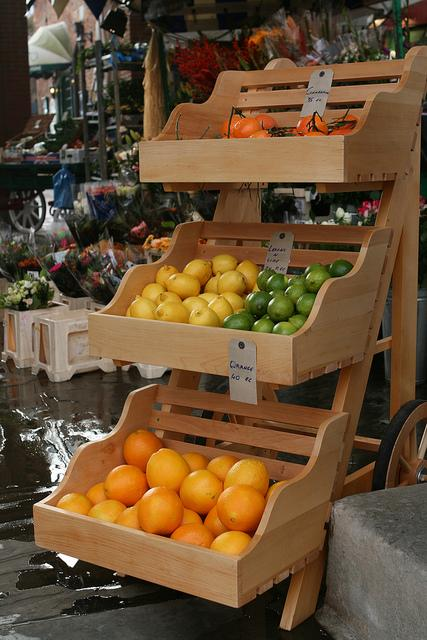The fruits in the raised wooden baskets seen here are all what? citrus 